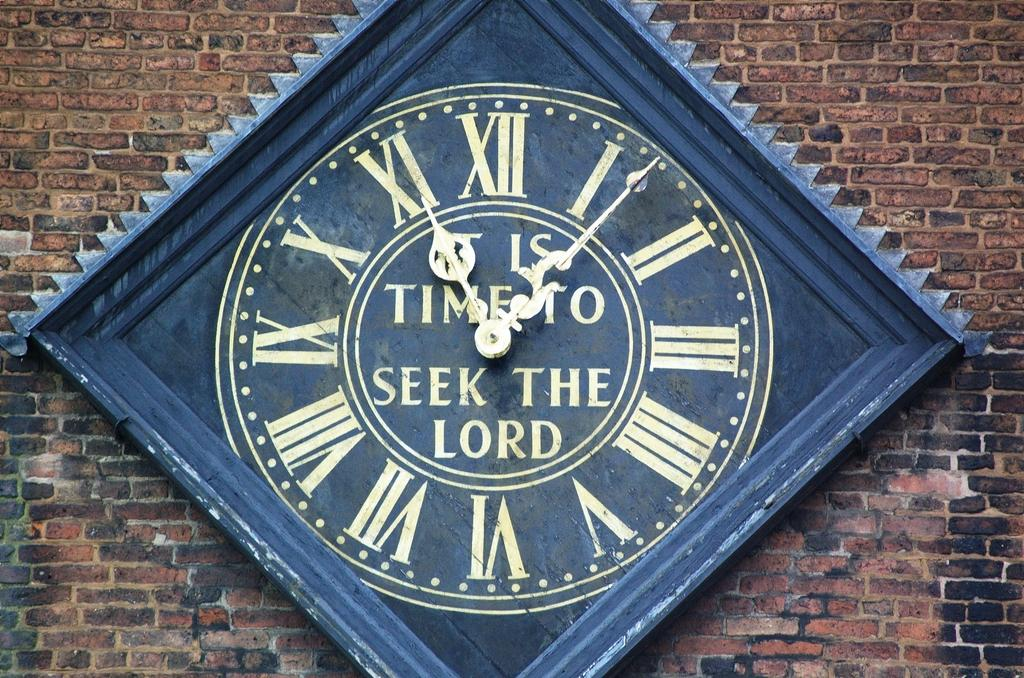<image>
Summarize the visual content of the image. A clock that states it is time to seek the lord. 